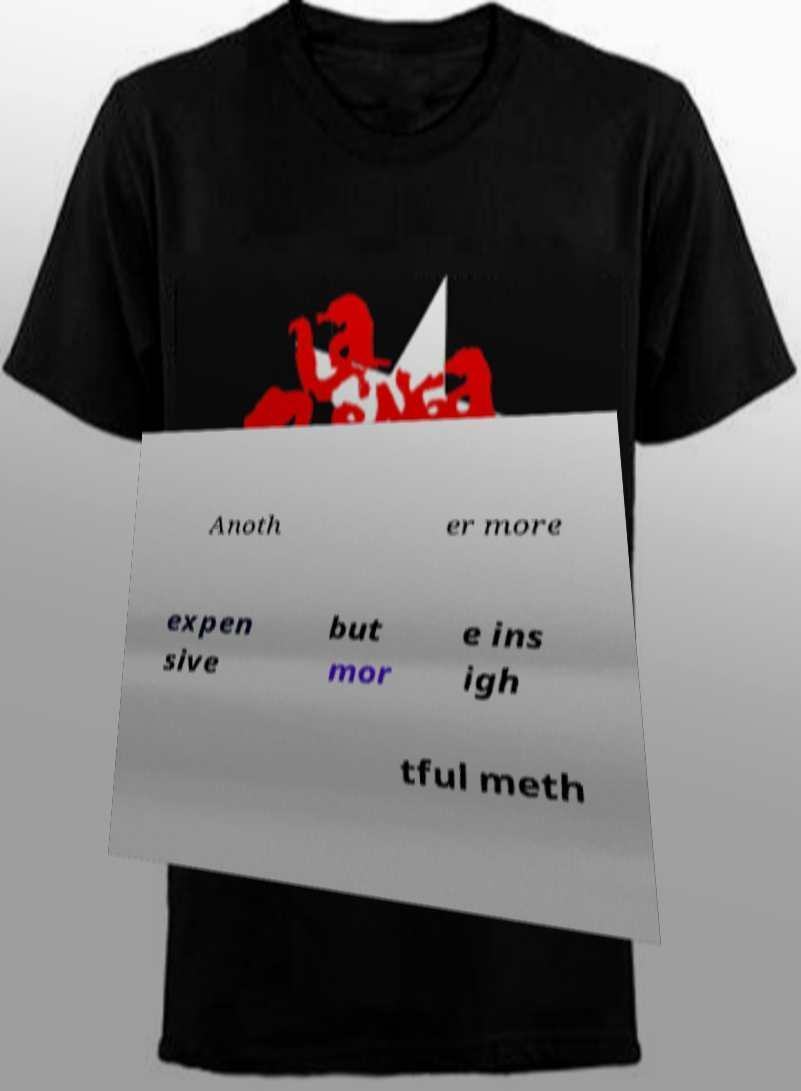What messages or text are displayed in this image? I need them in a readable, typed format. Anoth er more expen sive but mor e ins igh tful meth 